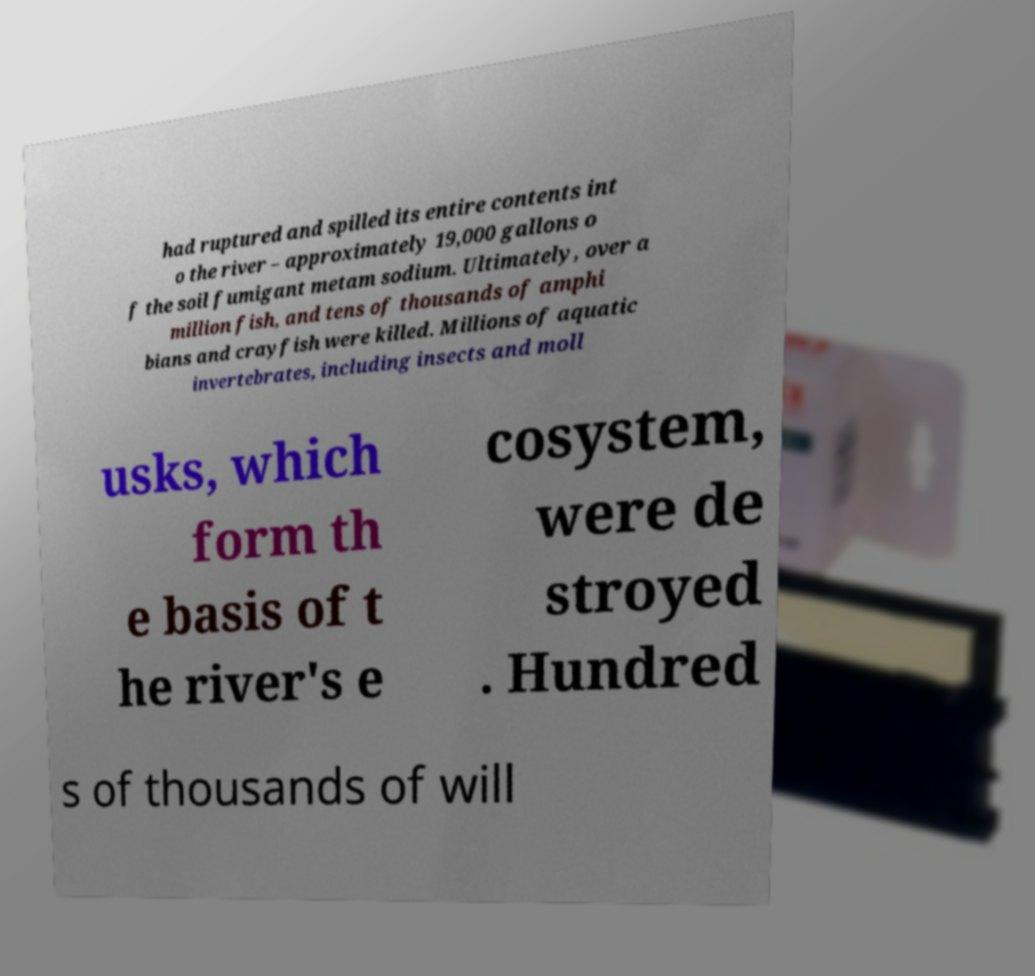Can you accurately transcribe the text from the provided image for me? had ruptured and spilled its entire contents int o the river – approximately 19,000 gallons o f the soil fumigant metam sodium. Ultimately, over a million fish, and tens of thousands of amphi bians and crayfish were killed. Millions of aquatic invertebrates, including insects and moll usks, which form th e basis of t he river's e cosystem, were de stroyed . Hundred s of thousands of will 